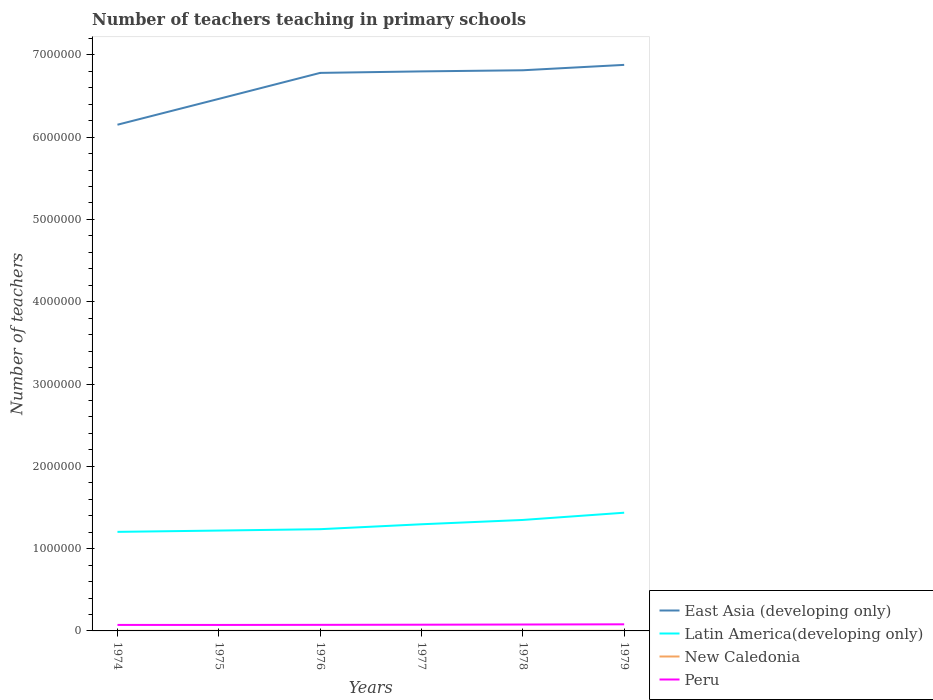Does the line corresponding to New Caledonia intersect with the line corresponding to East Asia (developing only)?
Offer a very short reply. No. Across all years, what is the maximum number of teachers teaching in primary schools in Latin America(developing only)?
Keep it short and to the point. 1.20e+06. In which year was the number of teachers teaching in primary schools in Peru maximum?
Provide a short and direct response. 1975. What is the total number of teachers teaching in primary schools in East Asia (developing only) in the graph?
Offer a terse response. -1.84e+04. What is the difference between the highest and the second highest number of teachers teaching in primary schools in New Caledonia?
Provide a succinct answer. 173. How many years are there in the graph?
Give a very brief answer. 6. Are the values on the major ticks of Y-axis written in scientific E-notation?
Offer a very short reply. No. Does the graph contain any zero values?
Your answer should be compact. No. Where does the legend appear in the graph?
Ensure brevity in your answer.  Bottom right. How are the legend labels stacked?
Ensure brevity in your answer.  Vertical. What is the title of the graph?
Make the answer very short. Number of teachers teaching in primary schools. Does "Italy" appear as one of the legend labels in the graph?
Ensure brevity in your answer.  No. What is the label or title of the Y-axis?
Your answer should be compact. Number of teachers. What is the Number of teachers in East Asia (developing only) in 1974?
Offer a terse response. 6.15e+06. What is the Number of teachers of Latin America(developing only) in 1974?
Offer a terse response. 1.20e+06. What is the Number of teachers in New Caledonia in 1974?
Your answer should be compact. 1149. What is the Number of teachers in Peru in 1974?
Your answer should be compact. 7.30e+04. What is the Number of teachers in East Asia (developing only) in 1975?
Provide a short and direct response. 6.47e+06. What is the Number of teachers of Latin America(developing only) in 1975?
Make the answer very short. 1.22e+06. What is the Number of teachers in New Caledonia in 1975?
Offer a very short reply. 1231. What is the Number of teachers of Peru in 1975?
Your answer should be very brief. 7.26e+04. What is the Number of teachers in East Asia (developing only) in 1976?
Your response must be concise. 6.78e+06. What is the Number of teachers in Latin America(developing only) in 1976?
Keep it short and to the point. 1.24e+06. What is the Number of teachers of New Caledonia in 1976?
Your answer should be very brief. 1275. What is the Number of teachers in Peru in 1976?
Your answer should be compact. 7.38e+04. What is the Number of teachers of East Asia (developing only) in 1977?
Give a very brief answer. 6.80e+06. What is the Number of teachers in Latin America(developing only) in 1977?
Provide a short and direct response. 1.30e+06. What is the Number of teachers of New Caledonia in 1977?
Offer a terse response. 1265. What is the Number of teachers in Peru in 1977?
Your answer should be compact. 7.55e+04. What is the Number of teachers of East Asia (developing only) in 1978?
Your answer should be compact. 6.81e+06. What is the Number of teachers in Latin America(developing only) in 1978?
Offer a terse response. 1.35e+06. What is the Number of teachers in New Caledonia in 1978?
Offer a very short reply. 1322. What is the Number of teachers in Peru in 1978?
Give a very brief answer. 7.78e+04. What is the Number of teachers of East Asia (developing only) in 1979?
Ensure brevity in your answer.  6.88e+06. What is the Number of teachers of Latin America(developing only) in 1979?
Offer a very short reply. 1.44e+06. What is the Number of teachers of New Caledonia in 1979?
Keep it short and to the point. 1318. What is the Number of teachers of Peru in 1979?
Your answer should be very brief. 8.03e+04. Across all years, what is the maximum Number of teachers of East Asia (developing only)?
Offer a terse response. 6.88e+06. Across all years, what is the maximum Number of teachers in Latin America(developing only)?
Your answer should be compact. 1.44e+06. Across all years, what is the maximum Number of teachers in New Caledonia?
Provide a succinct answer. 1322. Across all years, what is the maximum Number of teachers in Peru?
Provide a succinct answer. 8.03e+04. Across all years, what is the minimum Number of teachers of East Asia (developing only)?
Provide a short and direct response. 6.15e+06. Across all years, what is the minimum Number of teachers of Latin America(developing only)?
Give a very brief answer. 1.20e+06. Across all years, what is the minimum Number of teachers of New Caledonia?
Ensure brevity in your answer.  1149. Across all years, what is the minimum Number of teachers in Peru?
Ensure brevity in your answer.  7.26e+04. What is the total Number of teachers in East Asia (developing only) in the graph?
Your response must be concise. 3.99e+07. What is the total Number of teachers of Latin America(developing only) in the graph?
Provide a short and direct response. 7.74e+06. What is the total Number of teachers in New Caledonia in the graph?
Give a very brief answer. 7560. What is the total Number of teachers in Peru in the graph?
Offer a terse response. 4.53e+05. What is the difference between the Number of teachers of East Asia (developing only) in 1974 and that in 1975?
Your answer should be very brief. -3.14e+05. What is the difference between the Number of teachers of Latin America(developing only) in 1974 and that in 1975?
Give a very brief answer. -1.57e+04. What is the difference between the Number of teachers of New Caledonia in 1974 and that in 1975?
Your answer should be very brief. -82. What is the difference between the Number of teachers of Peru in 1974 and that in 1975?
Provide a short and direct response. 352. What is the difference between the Number of teachers of East Asia (developing only) in 1974 and that in 1976?
Offer a terse response. -6.30e+05. What is the difference between the Number of teachers in Latin America(developing only) in 1974 and that in 1976?
Your answer should be very brief. -3.25e+04. What is the difference between the Number of teachers in New Caledonia in 1974 and that in 1976?
Your answer should be very brief. -126. What is the difference between the Number of teachers in Peru in 1974 and that in 1976?
Provide a short and direct response. -856. What is the difference between the Number of teachers in East Asia (developing only) in 1974 and that in 1977?
Provide a short and direct response. -6.48e+05. What is the difference between the Number of teachers of Latin America(developing only) in 1974 and that in 1977?
Your response must be concise. -9.23e+04. What is the difference between the Number of teachers in New Caledonia in 1974 and that in 1977?
Ensure brevity in your answer.  -116. What is the difference between the Number of teachers in Peru in 1974 and that in 1977?
Provide a succinct answer. -2498. What is the difference between the Number of teachers in East Asia (developing only) in 1974 and that in 1978?
Your answer should be compact. -6.62e+05. What is the difference between the Number of teachers in Latin America(developing only) in 1974 and that in 1978?
Provide a short and direct response. -1.45e+05. What is the difference between the Number of teachers in New Caledonia in 1974 and that in 1978?
Provide a succinct answer. -173. What is the difference between the Number of teachers in Peru in 1974 and that in 1978?
Offer a terse response. -4851. What is the difference between the Number of teachers of East Asia (developing only) in 1974 and that in 1979?
Ensure brevity in your answer.  -7.27e+05. What is the difference between the Number of teachers in Latin America(developing only) in 1974 and that in 1979?
Provide a succinct answer. -2.33e+05. What is the difference between the Number of teachers of New Caledonia in 1974 and that in 1979?
Make the answer very short. -169. What is the difference between the Number of teachers in Peru in 1974 and that in 1979?
Your response must be concise. -7338. What is the difference between the Number of teachers in East Asia (developing only) in 1975 and that in 1976?
Make the answer very short. -3.16e+05. What is the difference between the Number of teachers of Latin America(developing only) in 1975 and that in 1976?
Your answer should be compact. -1.68e+04. What is the difference between the Number of teachers of New Caledonia in 1975 and that in 1976?
Give a very brief answer. -44. What is the difference between the Number of teachers in Peru in 1975 and that in 1976?
Offer a very short reply. -1208. What is the difference between the Number of teachers in East Asia (developing only) in 1975 and that in 1977?
Provide a succinct answer. -3.34e+05. What is the difference between the Number of teachers in Latin America(developing only) in 1975 and that in 1977?
Your answer should be very brief. -7.65e+04. What is the difference between the Number of teachers in New Caledonia in 1975 and that in 1977?
Offer a terse response. -34. What is the difference between the Number of teachers of Peru in 1975 and that in 1977?
Offer a terse response. -2850. What is the difference between the Number of teachers in East Asia (developing only) in 1975 and that in 1978?
Make the answer very short. -3.48e+05. What is the difference between the Number of teachers in Latin America(developing only) in 1975 and that in 1978?
Give a very brief answer. -1.29e+05. What is the difference between the Number of teachers in New Caledonia in 1975 and that in 1978?
Make the answer very short. -91. What is the difference between the Number of teachers in Peru in 1975 and that in 1978?
Make the answer very short. -5203. What is the difference between the Number of teachers in East Asia (developing only) in 1975 and that in 1979?
Make the answer very short. -4.13e+05. What is the difference between the Number of teachers in Latin America(developing only) in 1975 and that in 1979?
Offer a very short reply. -2.17e+05. What is the difference between the Number of teachers in New Caledonia in 1975 and that in 1979?
Make the answer very short. -87. What is the difference between the Number of teachers of Peru in 1975 and that in 1979?
Offer a very short reply. -7690. What is the difference between the Number of teachers of East Asia (developing only) in 1976 and that in 1977?
Your response must be concise. -1.84e+04. What is the difference between the Number of teachers of Latin America(developing only) in 1976 and that in 1977?
Provide a succinct answer. -5.97e+04. What is the difference between the Number of teachers of Peru in 1976 and that in 1977?
Keep it short and to the point. -1642. What is the difference between the Number of teachers in East Asia (developing only) in 1976 and that in 1978?
Ensure brevity in your answer.  -3.20e+04. What is the difference between the Number of teachers of Latin America(developing only) in 1976 and that in 1978?
Ensure brevity in your answer.  -1.12e+05. What is the difference between the Number of teachers in New Caledonia in 1976 and that in 1978?
Your response must be concise. -47. What is the difference between the Number of teachers in Peru in 1976 and that in 1978?
Your response must be concise. -3995. What is the difference between the Number of teachers in East Asia (developing only) in 1976 and that in 1979?
Provide a succinct answer. -9.75e+04. What is the difference between the Number of teachers of Latin America(developing only) in 1976 and that in 1979?
Keep it short and to the point. -2.00e+05. What is the difference between the Number of teachers of New Caledonia in 1976 and that in 1979?
Offer a terse response. -43. What is the difference between the Number of teachers of Peru in 1976 and that in 1979?
Your response must be concise. -6482. What is the difference between the Number of teachers in East Asia (developing only) in 1977 and that in 1978?
Make the answer very short. -1.37e+04. What is the difference between the Number of teachers of Latin America(developing only) in 1977 and that in 1978?
Keep it short and to the point. -5.25e+04. What is the difference between the Number of teachers in New Caledonia in 1977 and that in 1978?
Your answer should be compact. -57. What is the difference between the Number of teachers of Peru in 1977 and that in 1978?
Provide a short and direct response. -2353. What is the difference between the Number of teachers in East Asia (developing only) in 1977 and that in 1979?
Give a very brief answer. -7.91e+04. What is the difference between the Number of teachers in Latin America(developing only) in 1977 and that in 1979?
Make the answer very short. -1.40e+05. What is the difference between the Number of teachers in New Caledonia in 1977 and that in 1979?
Give a very brief answer. -53. What is the difference between the Number of teachers of Peru in 1977 and that in 1979?
Provide a short and direct response. -4840. What is the difference between the Number of teachers of East Asia (developing only) in 1978 and that in 1979?
Your answer should be compact. -6.55e+04. What is the difference between the Number of teachers in Latin America(developing only) in 1978 and that in 1979?
Keep it short and to the point. -8.79e+04. What is the difference between the Number of teachers in New Caledonia in 1978 and that in 1979?
Your answer should be very brief. 4. What is the difference between the Number of teachers in Peru in 1978 and that in 1979?
Give a very brief answer. -2487. What is the difference between the Number of teachers of East Asia (developing only) in 1974 and the Number of teachers of Latin America(developing only) in 1975?
Your answer should be very brief. 4.93e+06. What is the difference between the Number of teachers of East Asia (developing only) in 1974 and the Number of teachers of New Caledonia in 1975?
Ensure brevity in your answer.  6.15e+06. What is the difference between the Number of teachers of East Asia (developing only) in 1974 and the Number of teachers of Peru in 1975?
Give a very brief answer. 6.08e+06. What is the difference between the Number of teachers in Latin America(developing only) in 1974 and the Number of teachers in New Caledonia in 1975?
Make the answer very short. 1.20e+06. What is the difference between the Number of teachers of Latin America(developing only) in 1974 and the Number of teachers of Peru in 1975?
Offer a terse response. 1.13e+06. What is the difference between the Number of teachers in New Caledonia in 1974 and the Number of teachers in Peru in 1975?
Keep it short and to the point. -7.15e+04. What is the difference between the Number of teachers of East Asia (developing only) in 1974 and the Number of teachers of Latin America(developing only) in 1976?
Offer a terse response. 4.91e+06. What is the difference between the Number of teachers in East Asia (developing only) in 1974 and the Number of teachers in New Caledonia in 1976?
Make the answer very short. 6.15e+06. What is the difference between the Number of teachers in East Asia (developing only) in 1974 and the Number of teachers in Peru in 1976?
Give a very brief answer. 6.08e+06. What is the difference between the Number of teachers of Latin America(developing only) in 1974 and the Number of teachers of New Caledonia in 1976?
Your response must be concise. 1.20e+06. What is the difference between the Number of teachers in Latin America(developing only) in 1974 and the Number of teachers in Peru in 1976?
Provide a succinct answer. 1.13e+06. What is the difference between the Number of teachers of New Caledonia in 1974 and the Number of teachers of Peru in 1976?
Provide a short and direct response. -7.27e+04. What is the difference between the Number of teachers in East Asia (developing only) in 1974 and the Number of teachers in Latin America(developing only) in 1977?
Provide a succinct answer. 4.86e+06. What is the difference between the Number of teachers in East Asia (developing only) in 1974 and the Number of teachers in New Caledonia in 1977?
Provide a succinct answer. 6.15e+06. What is the difference between the Number of teachers in East Asia (developing only) in 1974 and the Number of teachers in Peru in 1977?
Offer a terse response. 6.08e+06. What is the difference between the Number of teachers in Latin America(developing only) in 1974 and the Number of teachers in New Caledonia in 1977?
Ensure brevity in your answer.  1.20e+06. What is the difference between the Number of teachers in Latin America(developing only) in 1974 and the Number of teachers in Peru in 1977?
Your answer should be very brief. 1.13e+06. What is the difference between the Number of teachers in New Caledonia in 1974 and the Number of teachers in Peru in 1977?
Offer a terse response. -7.43e+04. What is the difference between the Number of teachers of East Asia (developing only) in 1974 and the Number of teachers of Latin America(developing only) in 1978?
Make the answer very short. 4.80e+06. What is the difference between the Number of teachers of East Asia (developing only) in 1974 and the Number of teachers of New Caledonia in 1978?
Offer a terse response. 6.15e+06. What is the difference between the Number of teachers of East Asia (developing only) in 1974 and the Number of teachers of Peru in 1978?
Your response must be concise. 6.07e+06. What is the difference between the Number of teachers in Latin America(developing only) in 1974 and the Number of teachers in New Caledonia in 1978?
Provide a short and direct response. 1.20e+06. What is the difference between the Number of teachers of Latin America(developing only) in 1974 and the Number of teachers of Peru in 1978?
Ensure brevity in your answer.  1.13e+06. What is the difference between the Number of teachers of New Caledonia in 1974 and the Number of teachers of Peru in 1978?
Make the answer very short. -7.67e+04. What is the difference between the Number of teachers in East Asia (developing only) in 1974 and the Number of teachers in Latin America(developing only) in 1979?
Ensure brevity in your answer.  4.71e+06. What is the difference between the Number of teachers of East Asia (developing only) in 1974 and the Number of teachers of New Caledonia in 1979?
Keep it short and to the point. 6.15e+06. What is the difference between the Number of teachers in East Asia (developing only) in 1974 and the Number of teachers in Peru in 1979?
Your response must be concise. 6.07e+06. What is the difference between the Number of teachers in Latin America(developing only) in 1974 and the Number of teachers in New Caledonia in 1979?
Offer a very short reply. 1.20e+06. What is the difference between the Number of teachers of Latin America(developing only) in 1974 and the Number of teachers of Peru in 1979?
Give a very brief answer. 1.12e+06. What is the difference between the Number of teachers of New Caledonia in 1974 and the Number of teachers of Peru in 1979?
Offer a very short reply. -7.92e+04. What is the difference between the Number of teachers in East Asia (developing only) in 1975 and the Number of teachers in Latin America(developing only) in 1976?
Your answer should be compact. 5.23e+06. What is the difference between the Number of teachers of East Asia (developing only) in 1975 and the Number of teachers of New Caledonia in 1976?
Make the answer very short. 6.46e+06. What is the difference between the Number of teachers in East Asia (developing only) in 1975 and the Number of teachers in Peru in 1976?
Your answer should be very brief. 6.39e+06. What is the difference between the Number of teachers in Latin America(developing only) in 1975 and the Number of teachers in New Caledonia in 1976?
Give a very brief answer. 1.22e+06. What is the difference between the Number of teachers of Latin America(developing only) in 1975 and the Number of teachers of Peru in 1976?
Offer a terse response. 1.15e+06. What is the difference between the Number of teachers of New Caledonia in 1975 and the Number of teachers of Peru in 1976?
Your response must be concise. -7.26e+04. What is the difference between the Number of teachers of East Asia (developing only) in 1975 and the Number of teachers of Latin America(developing only) in 1977?
Keep it short and to the point. 5.17e+06. What is the difference between the Number of teachers in East Asia (developing only) in 1975 and the Number of teachers in New Caledonia in 1977?
Ensure brevity in your answer.  6.46e+06. What is the difference between the Number of teachers in East Asia (developing only) in 1975 and the Number of teachers in Peru in 1977?
Your response must be concise. 6.39e+06. What is the difference between the Number of teachers of Latin America(developing only) in 1975 and the Number of teachers of New Caledonia in 1977?
Make the answer very short. 1.22e+06. What is the difference between the Number of teachers of Latin America(developing only) in 1975 and the Number of teachers of Peru in 1977?
Offer a terse response. 1.14e+06. What is the difference between the Number of teachers of New Caledonia in 1975 and the Number of teachers of Peru in 1977?
Provide a succinct answer. -7.43e+04. What is the difference between the Number of teachers in East Asia (developing only) in 1975 and the Number of teachers in Latin America(developing only) in 1978?
Keep it short and to the point. 5.12e+06. What is the difference between the Number of teachers in East Asia (developing only) in 1975 and the Number of teachers in New Caledonia in 1978?
Make the answer very short. 6.46e+06. What is the difference between the Number of teachers of East Asia (developing only) in 1975 and the Number of teachers of Peru in 1978?
Your answer should be very brief. 6.39e+06. What is the difference between the Number of teachers in Latin America(developing only) in 1975 and the Number of teachers in New Caledonia in 1978?
Offer a very short reply. 1.22e+06. What is the difference between the Number of teachers in Latin America(developing only) in 1975 and the Number of teachers in Peru in 1978?
Give a very brief answer. 1.14e+06. What is the difference between the Number of teachers of New Caledonia in 1975 and the Number of teachers of Peru in 1978?
Your answer should be very brief. -7.66e+04. What is the difference between the Number of teachers of East Asia (developing only) in 1975 and the Number of teachers of Latin America(developing only) in 1979?
Ensure brevity in your answer.  5.03e+06. What is the difference between the Number of teachers in East Asia (developing only) in 1975 and the Number of teachers in New Caledonia in 1979?
Your answer should be compact. 6.46e+06. What is the difference between the Number of teachers of East Asia (developing only) in 1975 and the Number of teachers of Peru in 1979?
Offer a very short reply. 6.38e+06. What is the difference between the Number of teachers in Latin America(developing only) in 1975 and the Number of teachers in New Caledonia in 1979?
Provide a short and direct response. 1.22e+06. What is the difference between the Number of teachers of Latin America(developing only) in 1975 and the Number of teachers of Peru in 1979?
Offer a very short reply. 1.14e+06. What is the difference between the Number of teachers of New Caledonia in 1975 and the Number of teachers of Peru in 1979?
Give a very brief answer. -7.91e+04. What is the difference between the Number of teachers of East Asia (developing only) in 1976 and the Number of teachers of Latin America(developing only) in 1977?
Keep it short and to the point. 5.48e+06. What is the difference between the Number of teachers in East Asia (developing only) in 1976 and the Number of teachers in New Caledonia in 1977?
Give a very brief answer. 6.78e+06. What is the difference between the Number of teachers of East Asia (developing only) in 1976 and the Number of teachers of Peru in 1977?
Make the answer very short. 6.71e+06. What is the difference between the Number of teachers of Latin America(developing only) in 1976 and the Number of teachers of New Caledonia in 1977?
Ensure brevity in your answer.  1.23e+06. What is the difference between the Number of teachers in Latin America(developing only) in 1976 and the Number of teachers in Peru in 1977?
Your response must be concise. 1.16e+06. What is the difference between the Number of teachers of New Caledonia in 1976 and the Number of teachers of Peru in 1977?
Keep it short and to the point. -7.42e+04. What is the difference between the Number of teachers in East Asia (developing only) in 1976 and the Number of teachers in Latin America(developing only) in 1978?
Your answer should be compact. 5.43e+06. What is the difference between the Number of teachers of East Asia (developing only) in 1976 and the Number of teachers of New Caledonia in 1978?
Give a very brief answer. 6.78e+06. What is the difference between the Number of teachers of East Asia (developing only) in 1976 and the Number of teachers of Peru in 1978?
Keep it short and to the point. 6.70e+06. What is the difference between the Number of teachers in Latin America(developing only) in 1976 and the Number of teachers in New Caledonia in 1978?
Ensure brevity in your answer.  1.23e+06. What is the difference between the Number of teachers of Latin America(developing only) in 1976 and the Number of teachers of Peru in 1978?
Provide a succinct answer. 1.16e+06. What is the difference between the Number of teachers of New Caledonia in 1976 and the Number of teachers of Peru in 1978?
Ensure brevity in your answer.  -7.66e+04. What is the difference between the Number of teachers of East Asia (developing only) in 1976 and the Number of teachers of Latin America(developing only) in 1979?
Make the answer very short. 5.34e+06. What is the difference between the Number of teachers in East Asia (developing only) in 1976 and the Number of teachers in New Caledonia in 1979?
Provide a short and direct response. 6.78e+06. What is the difference between the Number of teachers in East Asia (developing only) in 1976 and the Number of teachers in Peru in 1979?
Provide a short and direct response. 6.70e+06. What is the difference between the Number of teachers of Latin America(developing only) in 1976 and the Number of teachers of New Caledonia in 1979?
Give a very brief answer. 1.23e+06. What is the difference between the Number of teachers of Latin America(developing only) in 1976 and the Number of teachers of Peru in 1979?
Your answer should be compact. 1.16e+06. What is the difference between the Number of teachers of New Caledonia in 1976 and the Number of teachers of Peru in 1979?
Give a very brief answer. -7.91e+04. What is the difference between the Number of teachers in East Asia (developing only) in 1977 and the Number of teachers in Latin America(developing only) in 1978?
Provide a succinct answer. 5.45e+06. What is the difference between the Number of teachers of East Asia (developing only) in 1977 and the Number of teachers of New Caledonia in 1978?
Provide a succinct answer. 6.80e+06. What is the difference between the Number of teachers in East Asia (developing only) in 1977 and the Number of teachers in Peru in 1978?
Provide a short and direct response. 6.72e+06. What is the difference between the Number of teachers in Latin America(developing only) in 1977 and the Number of teachers in New Caledonia in 1978?
Keep it short and to the point. 1.29e+06. What is the difference between the Number of teachers of Latin America(developing only) in 1977 and the Number of teachers of Peru in 1978?
Provide a succinct answer. 1.22e+06. What is the difference between the Number of teachers in New Caledonia in 1977 and the Number of teachers in Peru in 1978?
Offer a terse response. -7.66e+04. What is the difference between the Number of teachers of East Asia (developing only) in 1977 and the Number of teachers of Latin America(developing only) in 1979?
Give a very brief answer. 5.36e+06. What is the difference between the Number of teachers in East Asia (developing only) in 1977 and the Number of teachers in New Caledonia in 1979?
Make the answer very short. 6.80e+06. What is the difference between the Number of teachers in East Asia (developing only) in 1977 and the Number of teachers in Peru in 1979?
Offer a terse response. 6.72e+06. What is the difference between the Number of teachers in Latin America(developing only) in 1977 and the Number of teachers in New Caledonia in 1979?
Offer a terse response. 1.29e+06. What is the difference between the Number of teachers in Latin America(developing only) in 1977 and the Number of teachers in Peru in 1979?
Offer a very short reply. 1.22e+06. What is the difference between the Number of teachers in New Caledonia in 1977 and the Number of teachers in Peru in 1979?
Provide a succinct answer. -7.91e+04. What is the difference between the Number of teachers in East Asia (developing only) in 1978 and the Number of teachers in Latin America(developing only) in 1979?
Provide a succinct answer. 5.38e+06. What is the difference between the Number of teachers in East Asia (developing only) in 1978 and the Number of teachers in New Caledonia in 1979?
Keep it short and to the point. 6.81e+06. What is the difference between the Number of teachers of East Asia (developing only) in 1978 and the Number of teachers of Peru in 1979?
Provide a short and direct response. 6.73e+06. What is the difference between the Number of teachers of Latin America(developing only) in 1978 and the Number of teachers of New Caledonia in 1979?
Your answer should be compact. 1.35e+06. What is the difference between the Number of teachers of Latin America(developing only) in 1978 and the Number of teachers of Peru in 1979?
Your answer should be compact. 1.27e+06. What is the difference between the Number of teachers in New Caledonia in 1978 and the Number of teachers in Peru in 1979?
Provide a succinct answer. -7.90e+04. What is the average Number of teachers of East Asia (developing only) per year?
Your answer should be compact. 6.65e+06. What is the average Number of teachers in Latin America(developing only) per year?
Your answer should be very brief. 1.29e+06. What is the average Number of teachers of New Caledonia per year?
Make the answer very short. 1260. What is the average Number of teachers in Peru per year?
Your answer should be compact. 7.55e+04. In the year 1974, what is the difference between the Number of teachers of East Asia (developing only) and Number of teachers of Latin America(developing only)?
Offer a very short reply. 4.95e+06. In the year 1974, what is the difference between the Number of teachers of East Asia (developing only) and Number of teachers of New Caledonia?
Keep it short and to the point. 6.15e+06. In the year 1974, what is the difference between the Number of teachers in East Asia (developing only) and Number of teachers in Peru?
Provide a short and direct response. 6.08e+06. In the year 1974, what is the difference between the Number of teachers in Latin America(developing only) and Number of teachers in New Caledonia?
Make the answer very short. 1.20e+06. In the year 1974, what is the difference between the Number of teachers of Latin America(developing only) and Number of teachers of Peru?
Keep it short and to the point. 1.13e+06. In the year 1974, what is the difference between the Number of teachers in New Caledonia and Number of teachers in Peru?
Make the answer very short. -7.18e+04. In the year 1975, what is the difference between the Number of teachers in East Asia (developing only) and Number of teachers in Latin America(developing only)?
Provide a short and direct response. 5.25e+06. In the year 1975, what is the difference between the Number of teachers in East Asia (developing only) and Number of teachers in New Caledonia?
Your response must be concise. 6.46e+06. In the year 1975, what is the difference between the Number of teachers of East Asia (developing only) and Number of teachers of Peru?
Offer a very short reply. 6.39e+06. In the year 1975, what is the difference between the Number of teachers in Latin America(developing only) and Number of teachers in New Caledonia?
Your answer should be compact. 1.22e+06. In the year 1975, what is the difference between the Number of teachers of Latin America(developing only) and Number of teachers of Peru?
Offer a terse response. 1.15e+06. In the year 1975, what is the difference between the Number of teachers of New Caledonia and Number of teachers of Peru?
Keep it short and to the point. -7.14e+04. In the year 1976, what is the difference between the Number of teachers of East Asia (developing only) and Number of teachers of Latin America(developing only)?
Ensure brevity in your answer.  5.54e+06. In the year 1976, what is the difference between the Number of teachers in East Asia (developing only) and Number of teachers in New Caledonia?
Ensure brevity in your answer.  6.78e+06. In the year 1976, what is the difference between the Number of teachers in East Asia (developing only) and Number of teachers in Peru?
Your answer should be compact. 6.71e+06. In the year 1976, what is the difference between the Number of teachers of Latin America(developing only) and Number of teachers of New Caledonia?
Offer a very short reply. 1.23e+06. In the year 1976, what is the difference between the Number of teachers of Latin America(developing only) and Number of teachers of Peru?
Give a very brief answer. 1.16e+06. In the year 1976, what is the difference between the Number of teachers of New Caledonia and Number of teachers of Peru?
Ensure brevity in your answer.  -7.26e+04. In the year 1977, what is the difference between the Number of teachers of East Asia (developing only) and Number of teachers of Latin America(developing only)?
Make the answer very short. 5.50e+06. In the year 1977, what is the difference between the Number of teachers of East Asia (developing only) and Number of teachers of New Caledonia?
Give a very brief answer. 6.80e+06. In the year 1977, what is the difference between the Number of teachers of East Asia (developing only) and Number of teachers of Peru?
Offer a very short reply. 6.72e+06. In the year 1977, what is the difference between the Number of teachers of Latin America(developing only) and Number of teachers of New Caledonia?
Offer a very short reply. 1.29e+06. In the year 1977, what is the difference between the Number of teachers in Latin America(developing only) and Number of teachers in Peru?
Provide a succinct answer. 1.22e+06. In the year 1977, what is the difference between the Number of teachers of New Caledonia and Number of teachers of Peru?
Make the answer very short. -7.42e+04. In the year 1978, what is the difference between the Number of teachers of East Asia (developing only) and Number of teachers of Latin America(developing only)?
Provide a short and direct response. 5.46e+06. In the year 1978, what is the difference between the Number of teachers of East Asia (developing only) and Number of teachers of New Caledonia?
Make the answer very short. 6.81e+06. In the year 1978, what is the difference between the Number of teachers in East Asia (developing only) and Number of teachers in Peru?
Your response must be concise. 6.74e+06. In the year 1978, what is the difference between the Number of teachers of Latin America(developing only) and Number of teachers of New Caledonia?
Offer a very short reply. 1.35e+06. In the year 1978, what is the difference between the Number of teachers in Latin America(developing only) and Number of teachers in Peru?
Your answer should be very brief. 1.27e+06. In the year 1978, what is the difference between the Number of teachers in New Caledonia and Number of teachers in Peru?
Provide a short and direct response. -7.65e+04. In the year 1979, what is the difference between the Number of teachers of East Asia (developing only) and Number of teachers of Latin America(developing only)?
Your answer should be compact. 5.44e+06. In the year 1979, what is the difference between the Number of teachers of East Asia (developing only) and Number of teachers of New Caledonia?
Make the answer very short. 6.88e+06. In the year 1979, what is the difference between the Number of teachers in East Asia (developing only) and Number of teachers in Peru?
Give a very brief answer. 6.80e+06. In the year 1979, what is the difference between the Number of teachers in Latin America(developing only) and Number of teachers in New Caledonia?
Your answer should be very brief. 1.44e+06. In the year 1979, what is the difference between the Number of teachers of Latin America(developing only) and Number of teachers of Peru?
Make the answer very short. 1.36e+06. In the year 1979, what is the difference between the Number of teachers of New Caledonia and Number of teachers of Peru?
Give a very brief answer. -7.90e+04. What is the ratio of the Number of teachers in East Asia (developing only) in 1974 to that in 1975?
Your answer should be compact. 0.95. What is the ratio of the Number of teachers in Latin America(developing only) in 1974 to that in 1975?
Offer a terse response. 0.99. What is the ratio of the Number of teachers in New Caledonia in 1974 to that in 1975?
Provide a short and direct response. 0.93. What is the ratio of the Number of teachers in East Asia (developing only) in 1974 to that in 1976?
Ensure brevity in your answer.  0.91. What is the ratio of the Number of teachers of Latin America(developing only) in 1974 to that in 1976?
Your answer should be very brief. 0.97. What is the ratio of the Number of teachers in New Caledonia in 1974 to that in 1976?
Ensure brevity in your answer.  0.9. What is the ratio of the Number of teachers of Peru in 1974 to that in 1976?
Keep it short and to the point. 0.99. What is the ratio of the Number of teachers of East Asia (developing only) in 1974 to that in 1977?
Provide a succinct answer. 0.9. What is the ratio of the Number of teachers in Latin America(developing only) in 1974 to that in 1977?
Give a very brief answer. 0.93. What is the ratio of the Number of teachers of New Caledonia in 1974 to that in 1977?
Offer a very short reply. 0.91. What is the ratio of the Number of teachers in Peru in 1974 to that in 1977?
Keep it short and to the point. 0.97. What is the ratio of the Number of teachers of East Asia (developing only) in 1974 to that in 1978?
Make the answer very short. 0.9. What is the ratio of the Number of teachers of Latin America(developing only) in 1974 to that in 1978?
Give a very brief answer. 0.89. What is the ratio of the Number of teachers in New Caledonia in 1974 to that in 1978?
Keep it short and to the point. 0.87. What is the ratio of the Number of teachers in Peru in 1974 to that in 1978?
Ensure brevity in your answer.  0.94. What is the ratio of the Number of teachers in East Asia (developing only) in 1974 to that in 1979?
Your response must be concise. 0.89. What is the ratio of the Number of teachers of Latin America(developing only) in 1974 to that in 1979?
Your response must be concise. 0.84. What is the ratio of the Number of teachers in New Caledonia in 1974 to that in 1979?
Your response must be concise. 0.87. What is the ratio of the Number of teachers in Peru in 1974 to that in 1979?
Make the answer very short. 0.91. What is the ratio of the Number of teachers in East Asia (developing only) in 1975 to that in 1976?
Give a very brief answer. 0.95. What is the ratio of the Number of teachers in Latin America(developing only) in 1975 to that in 1976?
Provide a short and direct response. 0.99. What is the ratio of the Number of teachers in New Caledonia in 1975 to that in 1976?
Provide a short and direct response. 0.97. What is the ratio of the Number of teachers of Peru in 1975 to that in 1976?
Provide a succinct answer. 0.98. What is the ratio of the Number of teachers in East Asia (developing only) in 1975 to that in 1977?
Provide a succinct answer. 0.95. What is the ratio of the Number of teachers in Latin America(developing only) in 1975 to that in 1977?
Keep it short and to the point. 0.94. What is the ratio of the Number of teachers of New Caledonia in 1975 to that in 1977?
Your answer should be very brief. 0.97. What is the ratio of the Number of teachers in Peru in 1975 to that in 1977?
Give a very brief answer. 0.96. What is the ratio of the Number of teachers in East Asia (developing only) in 1975 to that in 1978?
Your response must be concise. 0.95. What is the ratio of the Number of teachers in Latin America(developing only) in 1975 to that in 1978?
Ensure brevity in your answer.  0.9. What is the ratio of the Number of teachers of New Caledonia in 1975 to that in 1978?
Your response must be concise. 0.93. What is the ratio of the Number of teachers in Peru in 1975 to that in 1978?
Ensure brevity in your answer.  0.93. What is the ratio of the Number of teachers in East Asia (developing only) in 1975 to that in 1979?
Offer a very short reply. 0.94. What is the ratio of the Number of teachers in Latin America(developing only) in 1975 to that in 1979?
Your answer should be compact. 0.85. What is the ratio of the Number of teachers of New Caledonia in 1975 to that in 1979?
Your answer should be compact. 0.93. What is the ratio of the Number of teachers of Peru in 1975 to that in 1979?
Keep it short and to the point. 0.9. What is the ratio of the Number of teachers in Latin America(developing only) in 1976 to that in 1977?
Keep it short and to the point. 0.95. What is the ratio of the Number of teachers of New Caledonia in 1976 to that in 1977?
Your answer should be very brief. 1.01. What is the ratio of the Number of teachers in Peru in 1976 to that in 1977?
Offer a very short reply. 0.98. What is the ratio of the Number of teachers in East Asia (developing only) in 1976 to that in 1978?
Provide a short and direct response. 1. What is the ratio of the Number of teachers in Latin America(developing only) in 1976 to that in 1978?
Keep it short and to the point. 0.92. What is the ratio of the Number of teachers in New Caledonia in 1976 to that in 1978?
Provide a succinct answer. 0.96. What is the ratio of the Number of teachers of Peru in 1976 to that in 1978?
Keep it short and to the point. 0.95. What is the ratio of the Number of teachers in East Asia (developing only) in 1976 to that in 1979?
Offer a very short reply. 0.99. What is the ratio of the Number of teachers of Latin America(developing only) in 1976 to that in 1979?
Keep it short and to the point. 0.86. What is the ratio of the Number of teachers in New Caledonia in 1976 to that in 1979?
Your response must be concise. 0.97. What is the ratio of the Number of teachers of Peru in 1976 to that in 1979?
Your answer should be compact. 0.92. What is the ratio of the Number of teachers in Latin America(developing only) in 1977 to that in 1978?
Offer a terse response. 0.96. What is the ratio of the Number of teachers in New Caledonia in 1977 to that in 1978?
Ensure brevity in your answer.  0.96. What is the ratio of the Number of teachers in Peru in 1977 to that in 1978?
Make the answer very short. 0.97. What is the ratio of the Number of teachers in Latin America(developing only) in 1977 to that in 1979?
Provide a short and direct response. 0.9. What is the ratio of the Number of teachers of New Caledonia in 1977 to that in 1979?
Your response must be concise. 0.96. What is the ratio of the Number of teachers of Peru in 1977 to that in 1979?
Provide a succinct answer. 0.94. What is the ratio of the Number of teachers in East Asia (developing only) in 1978 to that in 1979?
Your response must be concise. 0.99. What is the ratio of the Number of teachers in Latin America(developing only) in 1978 to that in 1979?
Your answer should be compact. 0.94. What is the difference between the highest and the second highest Number of teachers of East Asia (developing only)?
Provide a succinct answer. 6.55e+04. What is the difference between the highest and the second highest Number of teachers in Latin America(developing only)?
Your answer should be compact. 8.79e+04. What is the difference between the highest and the second highest Number of teachers of Peru?
Give a very brief answer. 2487. What is the difference between the highest and the lowest Number of teachers in East Asia (developing only)?
Give a very brief answer. 7.27e+05. What is the difference between the highest and the lowest Number of teachers in Latin America(developing only)?
Provide a succinct answer. 2.33e+05. What is the difference between the highest and the lowest Number of teachers of New Caledonia?
Provide a short and direct response. 173. What is the difference between the highest and the lowest Number of teachers in Peru?
Offer a very short reply. 7690. 